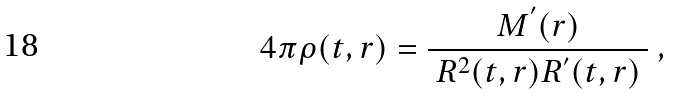Convert formula to latex. <formula><loc_0><loc_0><loc_500><loc_500>4 \pi \rho ( t , r ) = \frac { M ^ { ^ { \prime } } ( r ) } { \ R ^ { 2 } ( t , r ) R ^ { ^ { \prime } } ( t , r ) \ } \ ,</formula> 